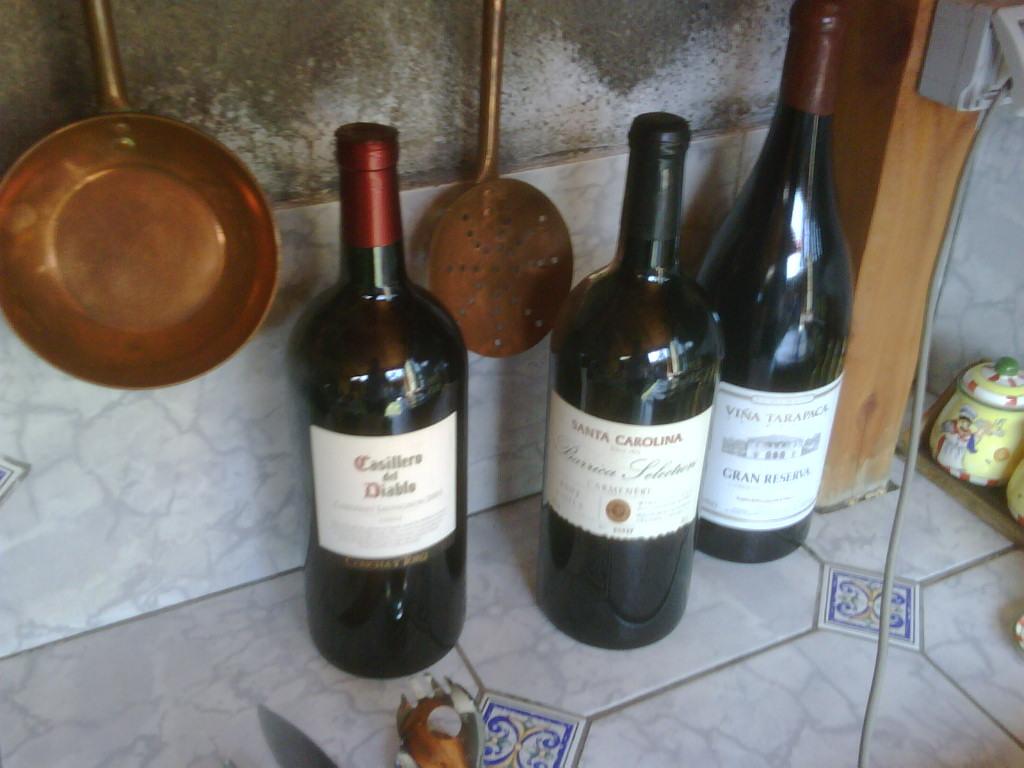What is the brand of wine on the far left?
Provide a succinct answer. Casillero del diablo. 